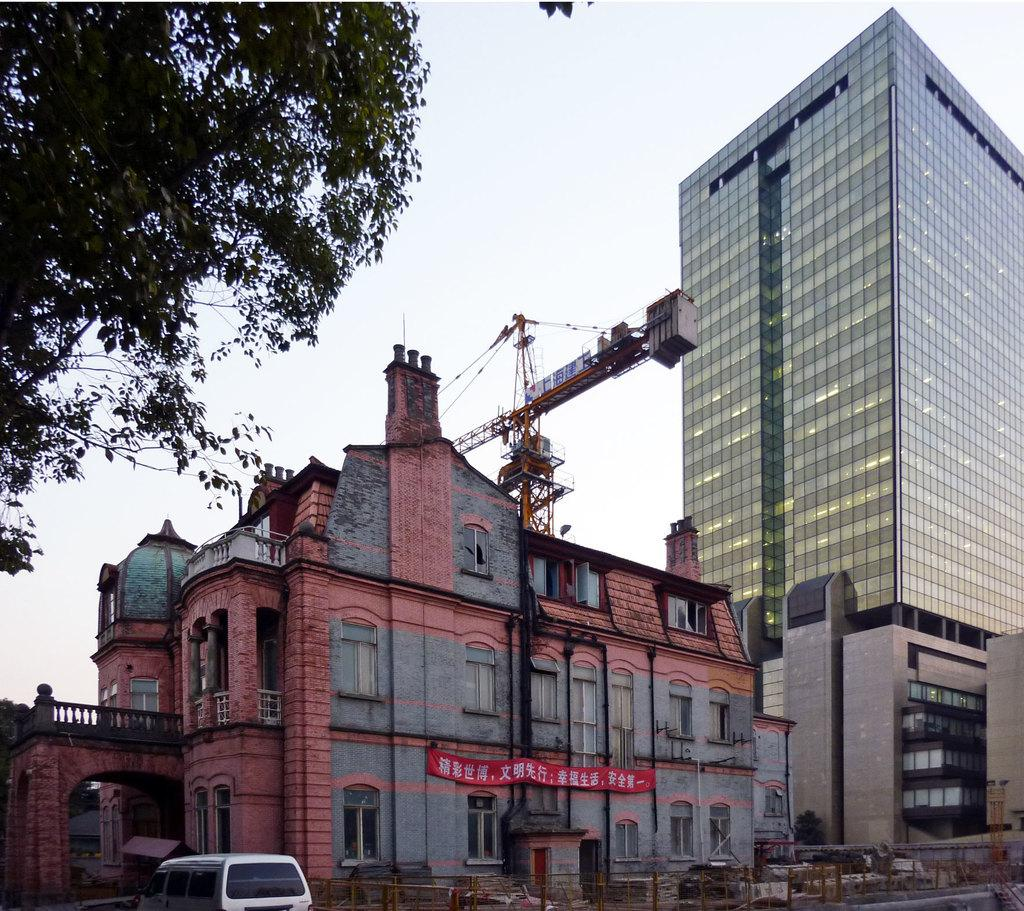What type of structures can be seen in the image? There are buildings in the image. What feature of the buildings is visible? There are windows visible in the image. What natural element is present in the image? There is a tree in the image. What man-made object can be seen in the image? There is a vehicle in the image. What type of barrier is present in the image? There is a fencing in the image. What additional textual element is present in the image? There is a banner with text in the image. What part of the natural environment is visible in the image? The sky is visible in the image. What letter is being dropped from the banner in the image? There is no letter being dropped from the banner in the image; it is a stationary banner with text. What type of protest is taking place in the image? There is no protest present in the image; it features buildings, windows, a tree, a vehicle, fencing, a banner, and the sky. 